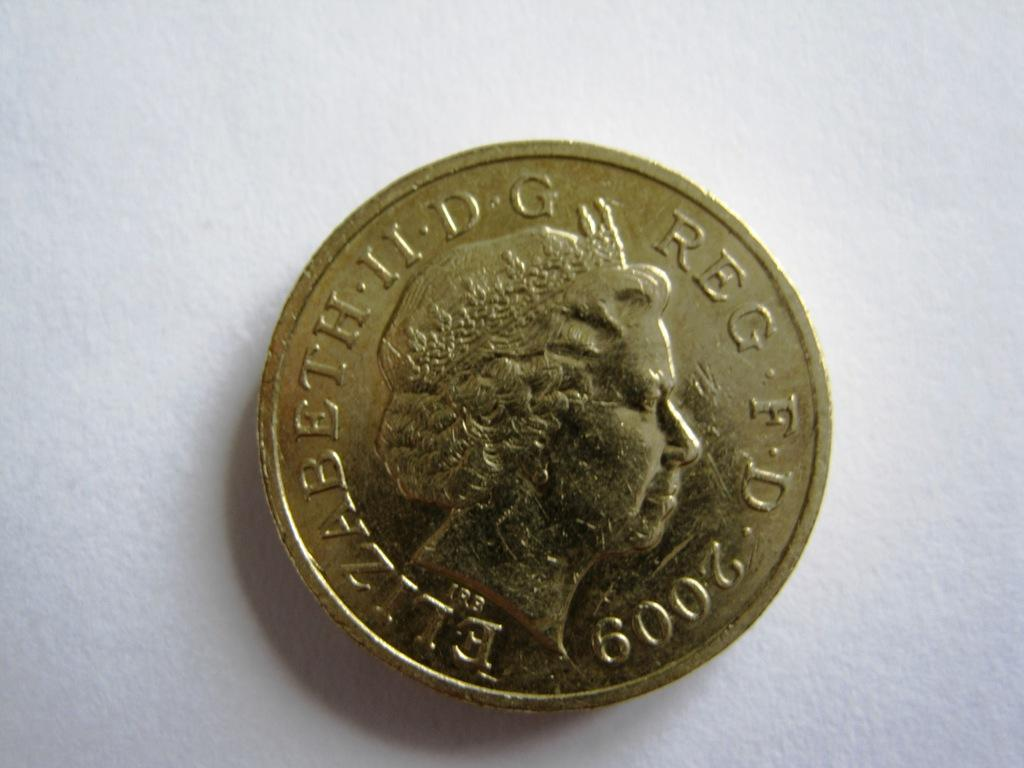What object is the main focus of the image? There is a coin in the image. What is featured on the coin? There is a woman depicted on the coin. What other elements can be seen on the coin? There is text and a number on the coin. What is the color of the background in the image? The background of the image is white in color. Can you tell me how many insects are crawling on the coin in the image? There are no insects present on the coin in the image. What type of society is depicted on the coin? The coin does not depict any society; it features a woman and other elements as described in the facts. 